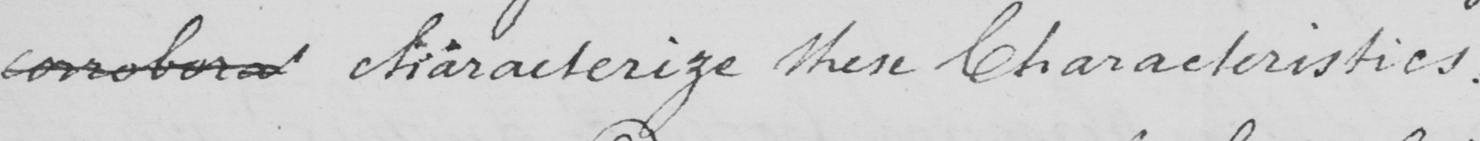Please transcribe the handwritten text in this image. corrobora characterize these Characteristics . 